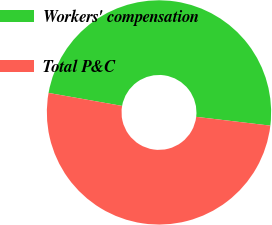Convert chart to OTSL. <chart><loc_0><loc_0><loc_500><loc_500><pie_chart><fcel>Workers' compensation<fcel>Total P&C<nl><fcel>49.1%<fcel>50.9%<nl></chart> 